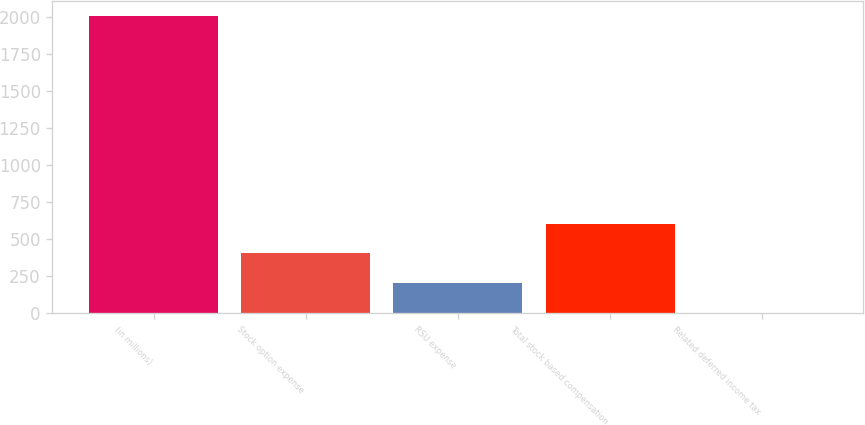Convert chart to OTSL. <chart><loc_0><loc_0><loc_500><loc_500><bar_chart><fcel>(in millions)<fcel>Stock option expense<fcel>RSU expense<fcel>Total stock based compensation<fcel>Related deferred income tax<nl><fcel>2008<fcel>404.72<fcel>204.31<fcel>605.13<fcel>3.9<nl></chart> 